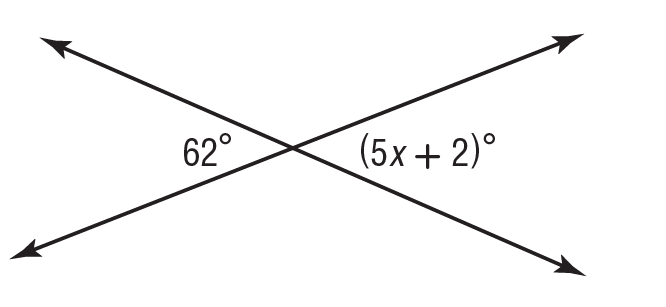Question: What is the value of x in the figure?
Choices:
A. 10
B. 12
C. 14
D. 15
Answer with the letter. Answer: B 